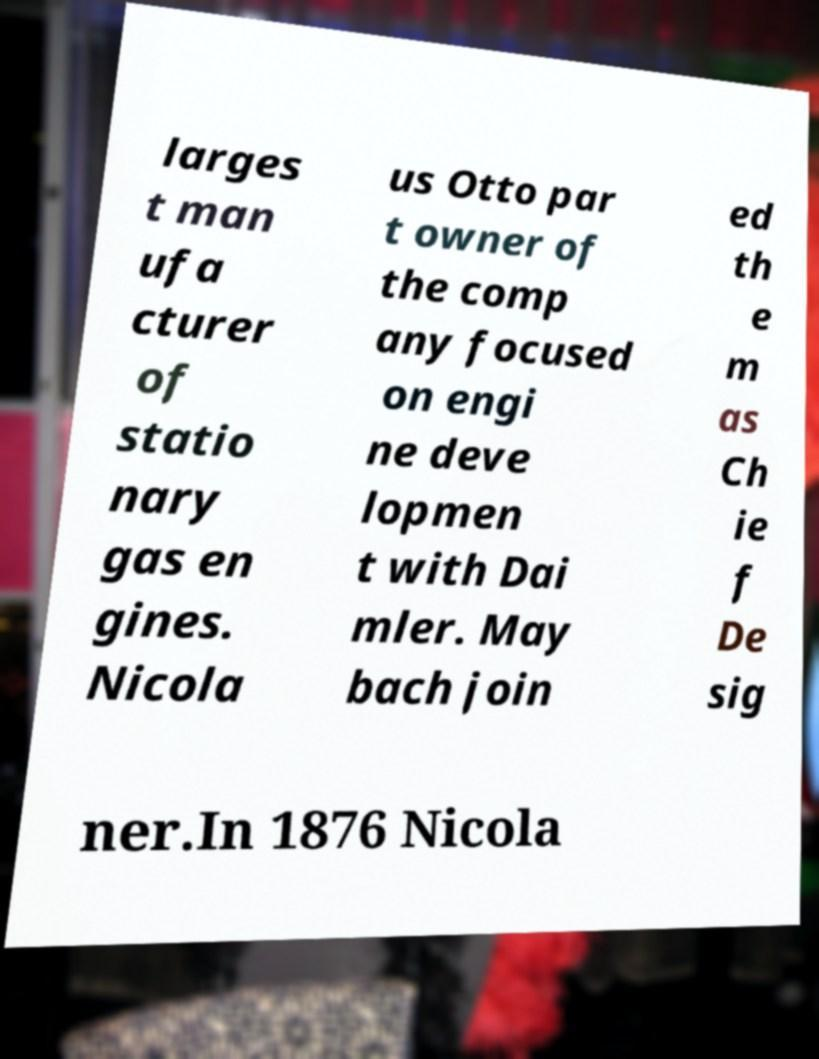Can you accurately transcribe the text from the provided image for me? larges t man ufa cturer of statio nary gas en gines. Nicola us Otto par t owner of the comp any focused on engi ne deve lopmen t with Dai mler. May bach join ed th e m as Ch ie f De sig ner.In 1876 Nicola 